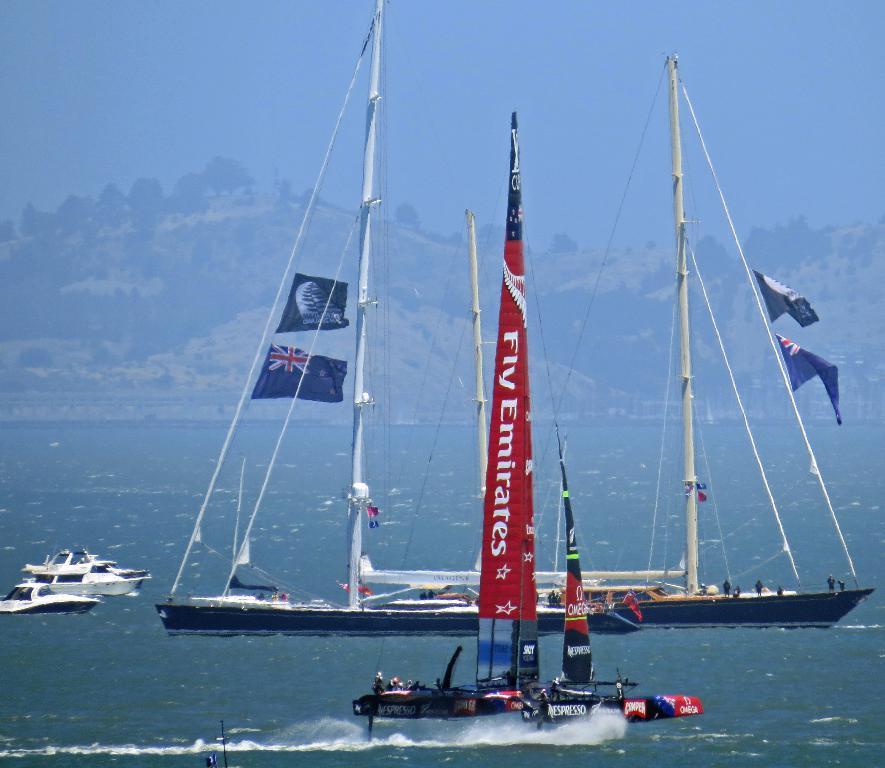In one or two sentences, can you explain what this image depicts? This is the picture of a sea. In this image there are boats and ships on the water. There are flags on the boats. At the back there are mountains and there are trees on the mountains. At the top there is sky. At the bottom there is water. 